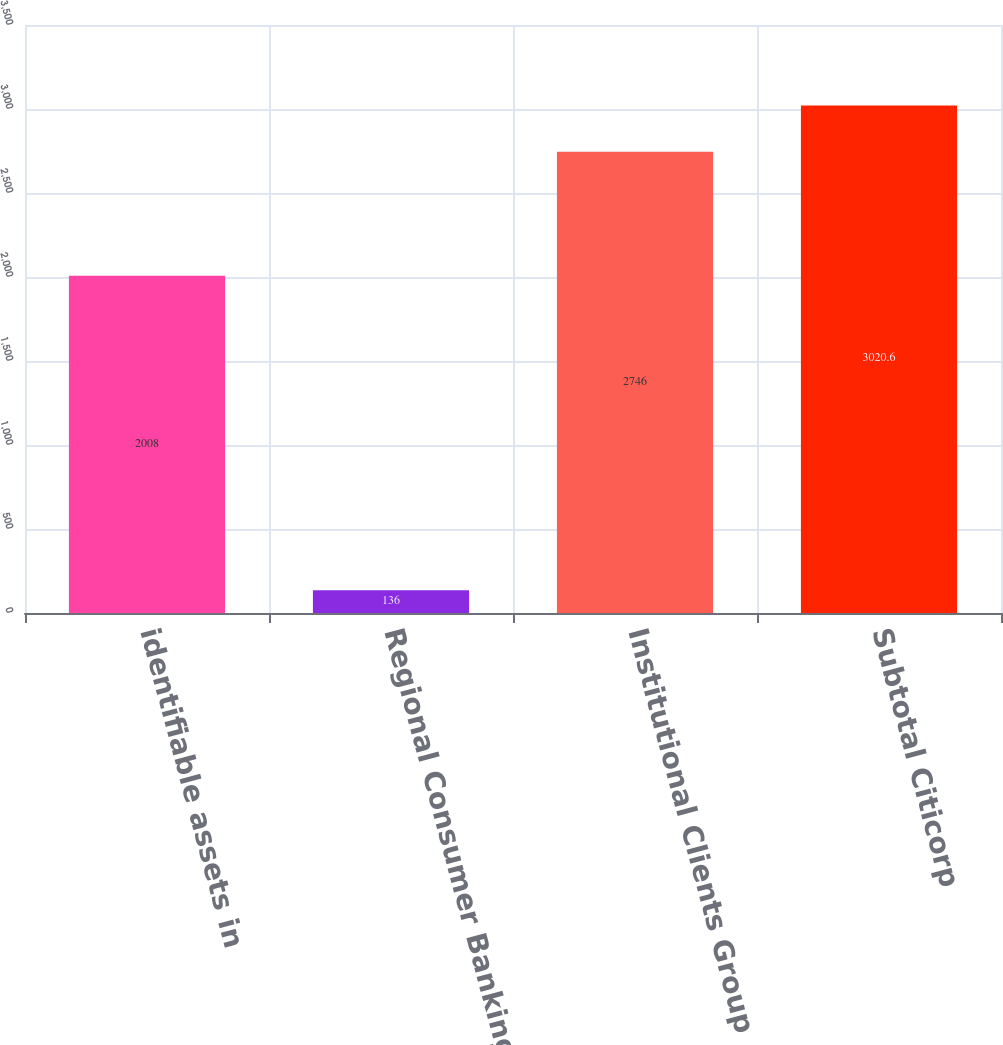Convert chart to OTSL. <chart><loc_0><loc_0><loc_500><loc_500><bar_chart><fcel>identifiable assets in<fcel>Regional Consumer Banking<fcel>Institutional Clients Group<fcel>Subtotal Citicorp<nl><fcel>2008<fcel>136<fcel>2746<fcel>3020.6<nl></chart> 